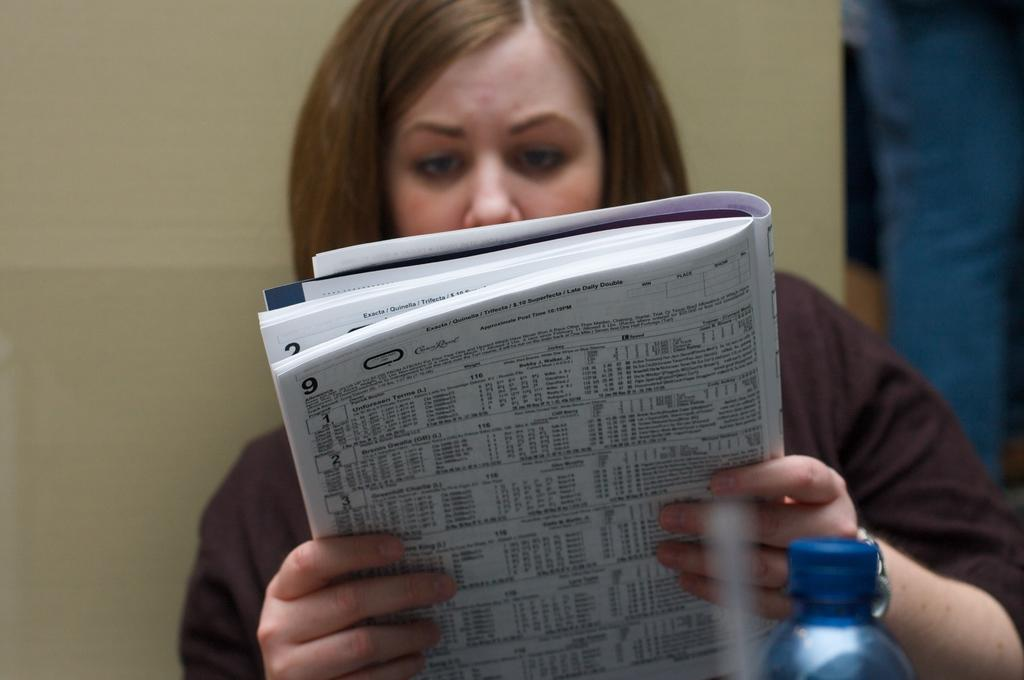Who is the main subject in the image? There is a lady in the image. What is the lady holding in the image? The lady is holding a book. What object is in front of the lady? There is a bottle in front of the lady. What color is the wall behind the lady? There is a yellow wall behind the lady. What type of skirt is the lady wearing in the image? The image does not show the lady wearing a skirt, so it cannot be determined from the image. 